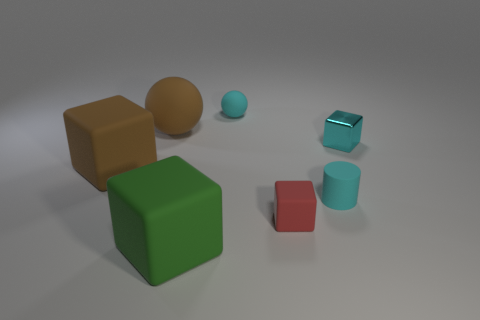Can you infer any relationships or interactions between the objects? While the objects are static and do not interact in a physical sense, their arrangement can suggest relationships. For example, the close proximity of the green and red cubes could be seen as a pairing, while the cyan-colored objects appear to form a gradient of shapes from a cube to a cylinder, showing a progression in form. 